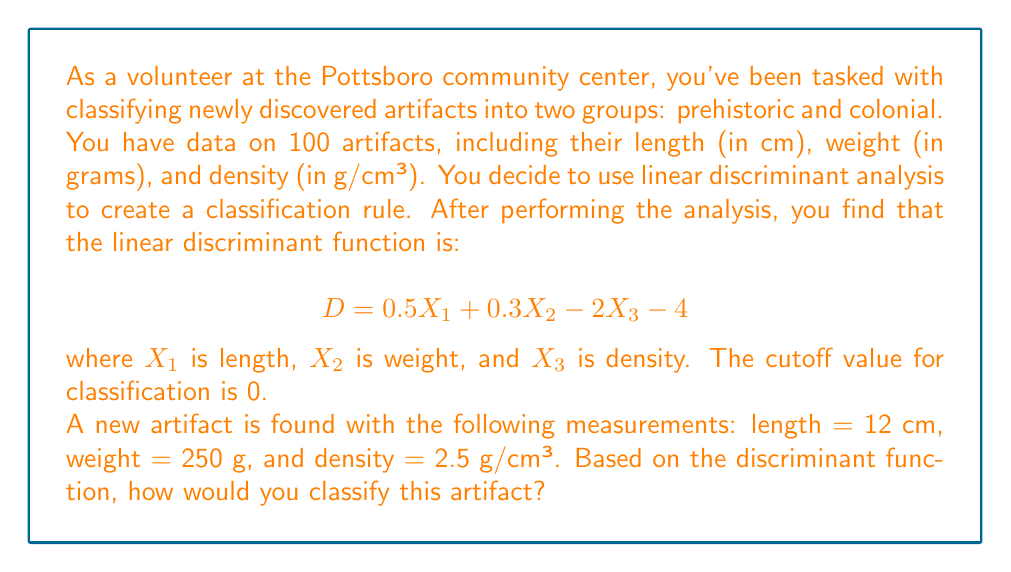Teach me how to tackle this problem. To solve this problem, we need to follow these steps:

1. Understand the discriminant function:
   The function $D = 0.5X_1 + 0.3X_2 - 2X_3 - 4$ is used to classify artifacts.
   
2. Know the classification rule:
   If $D > 0$, classify as prehistoric.
   If $D < 0$, classify as colonial.
   If $D = 0$, it's on the decision boundary.

3. Input the values of the new artifact into the discriminant function:
   $X_1 = 12$ (length)
   $X_2 = 250$ (weight)
   $X_3 = 2.5$ (density)

4. Calculate the discriminant score:

   $$\begin{align}
   D &= 0.5X_1 + 0.3X_2 - 2X_3 - 4 \\
   &= 0.5(12) + 0.3(250) - 2(2.5) - 4 \\
   &= 6 + 75 - 5 - 4 \\
   &= 72
   \end{align}$$

5. Interpret the result:
   Since $D = 72 > 0$, we classify this artifact as prehistoric.

This method allows us to classify artifacts based on multiple characteristics simultaneously, which is more robust than using a single measurement for classification.
Answer: The artifact would be classified as prehistoric because the discriminant score $D = 72 > 0$. 